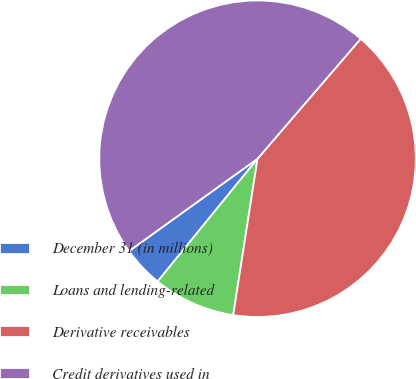<chart> <loc_0><loc_0><loc_500><loc_500><pie_chart><fcel>December 31 (in millions)<fcel>Loans and lending-related<fcel>Derivative receivables<fcel>Credit derivatives used in<nl><fcel>4.21%<fcel>8.42%<fcel>41.15%<fcel>46.23%<nl></chart> 